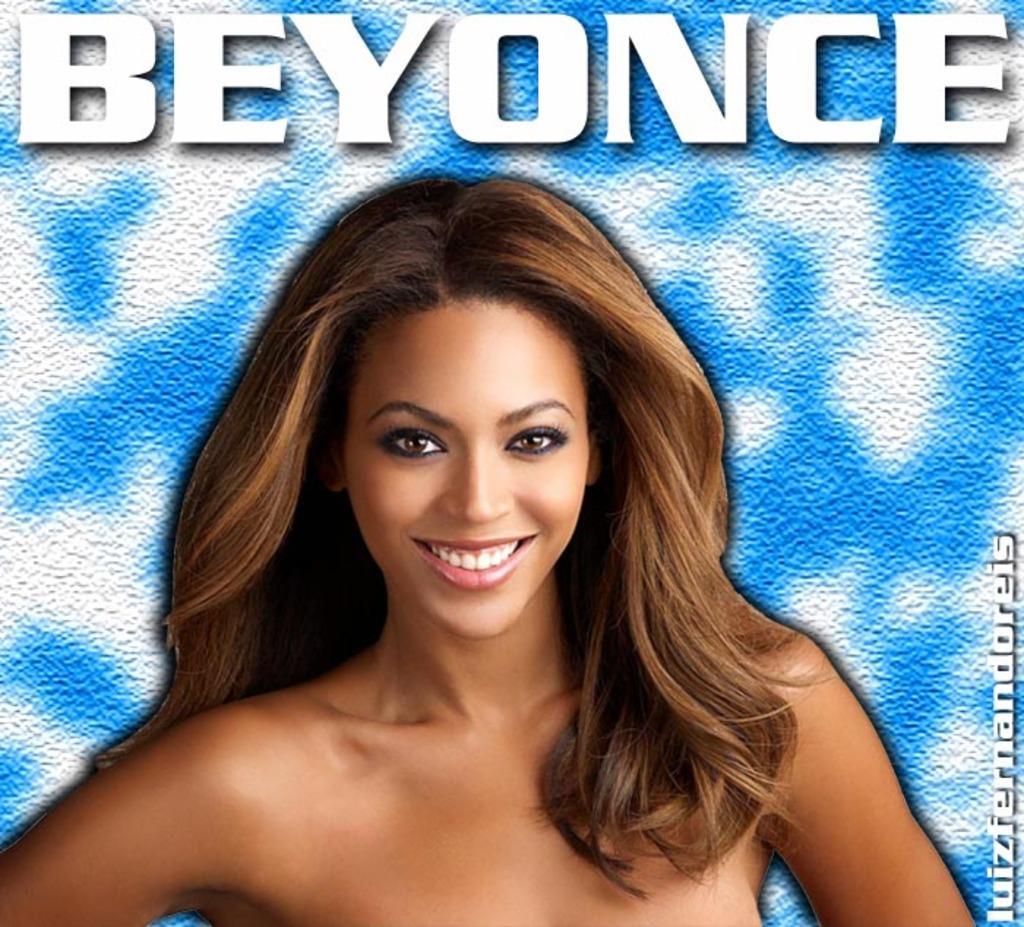Describe this image in one or two sentences. This is an edited picture where in the foreground, there is a woman with brown hair and having smile on her face and there is a blue and white background and on the top, there is text written as ¨ BEYONCE¨. 